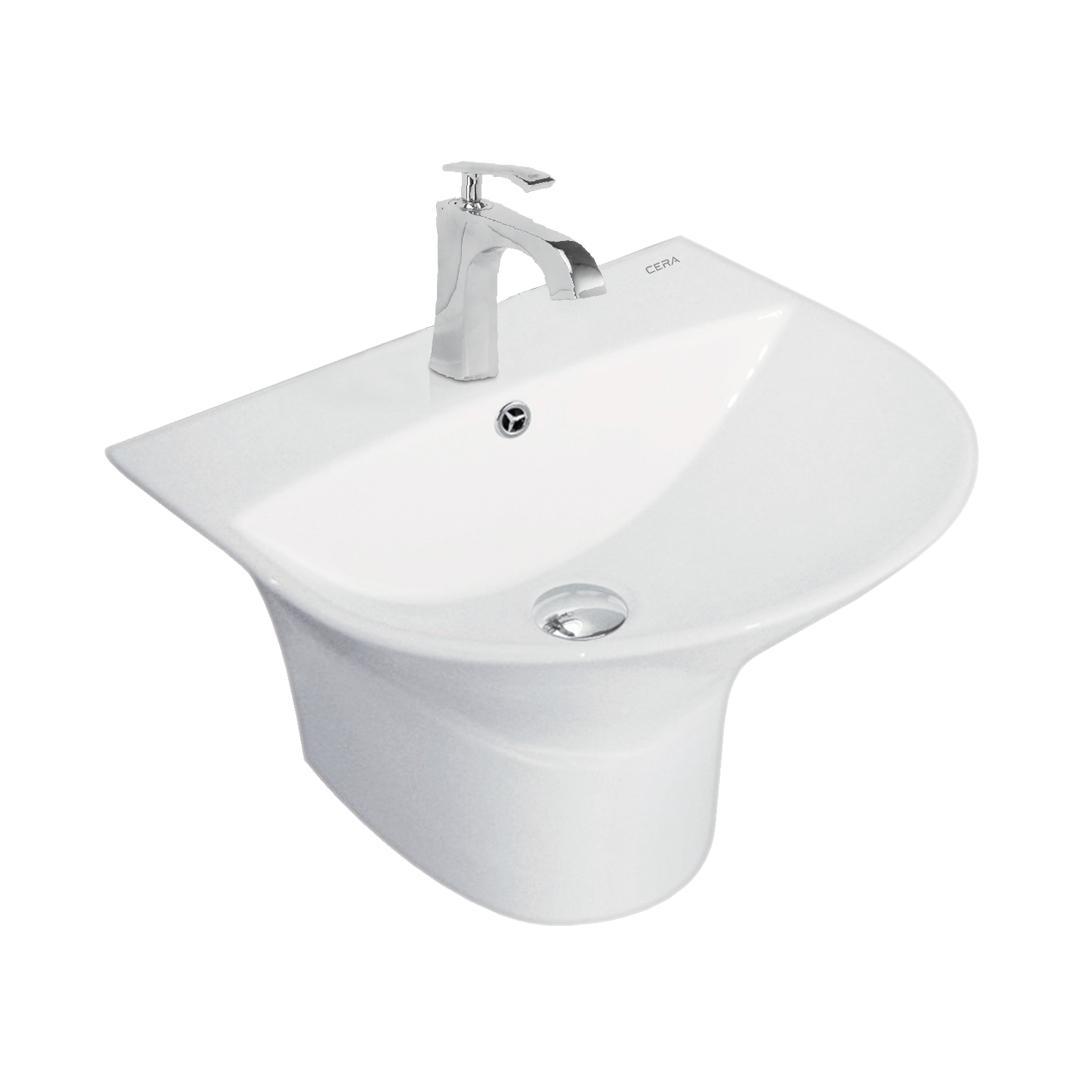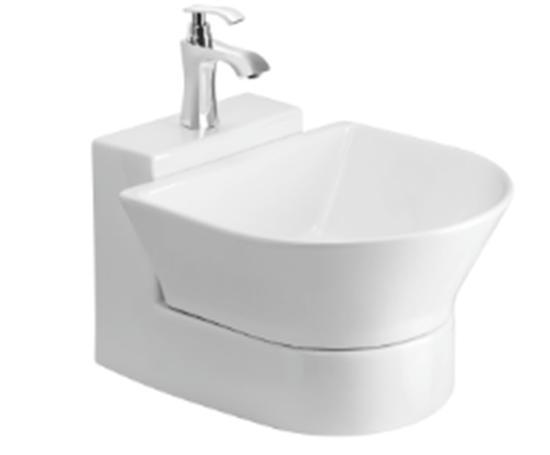The first image is the image on the left, the second image is the image on the right. Given the left and right images, does the statement "The right-hand sink is rectangular rather than rounded." hold true? Answer yes or no. No. 